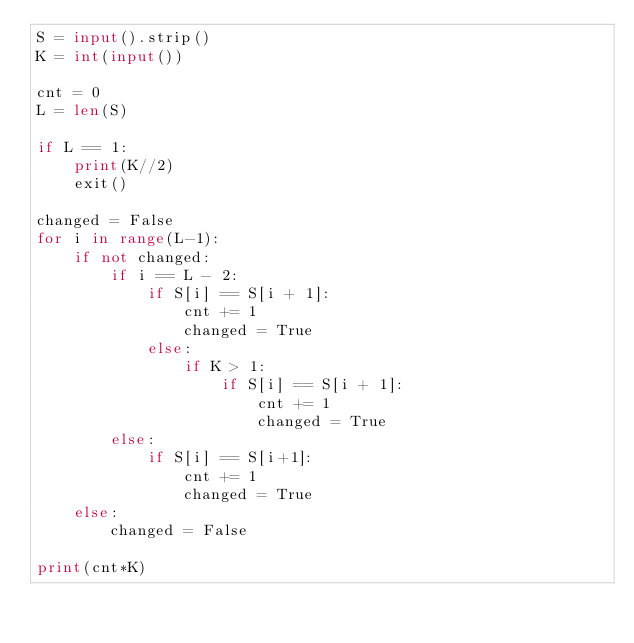Convert code to text. <code><loc_0><loc_0><loc_500><loc_500><_Python_>S = input().strip()
K = int(input())

cnt = 0
L = len(S)

if L == 1:
    print(K//2)
    exit()

changed = False
for i in range(L-1):
    if not changed:
        if i == L - 2:
            if S[i] == S[i + 1]:
                cnt += 1
                changed = True
            else:
                if K > 1:
                    if S[i] == S[i + 1]:
                        cnt += 1
                        changed = True
        else:
            if S[i] == S[i+1]:
                cnt += 1
                changed = True
    else:
        changed = False

print(cnt*K)



</code> 